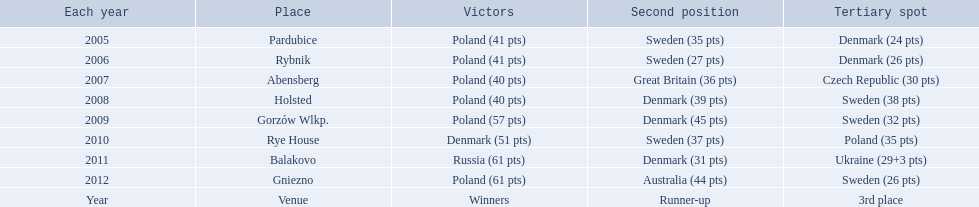Can you give me this table as a dict? {'header': ['Each year', 'Place', 'Victors', 'Second position', 'Tertiary spot'], 'rows': [['2005', 'Pardubice', 'Poland (41 pts)', 'Sweden (35 pts)', 'Denmark (24 pts)'], ['2006', 'Rybnik', 'Poland (41 pts)', 'Sweden (27 pts)', 'Denmark (26 pts)'], ['2007', 'Abensberg', 'Poland (40 pts)', 'Great Britain (36 pts)', 'Czech Republic (30 pts)'], ['2008', 'Holsted', 'Poland (40 pts)', 'Denmark (39 pts)', 'Sweden (38 pts)'], ['2009', 'Gorzów Wlkp.', 'Poland (57 pts)', 'Denmark (45 pts)', 'Sweden (32 pts)'], ['2010', 'Rye House', 'Denmark (51 pts)', 'Sweden (37 pts)', 'Poland (35 pts)'], ['2011', 'Balakovo', 'Russia (61 pts)', 'Denmark (31 pts)', 'Ukraine (29+3 pts)'], ['2012', 'Gniezno', 'Poland (61 pts)', 'Australia (44 pts)', 'Sweden (26 pts)'], ['Year', 'Venue', 'Winners', 'Runner-up', '3rd place']]} In what years did denmark place in the top 3 in the team speedway junior world championship? 2005, 2006, 2008, 2009, 2010, 2011. What in what year did denmark come withing 2 points of placing higher in the standings? 2006. What place did denmark receive the year they missed higher ranking by only 2 points? 3rd place. 